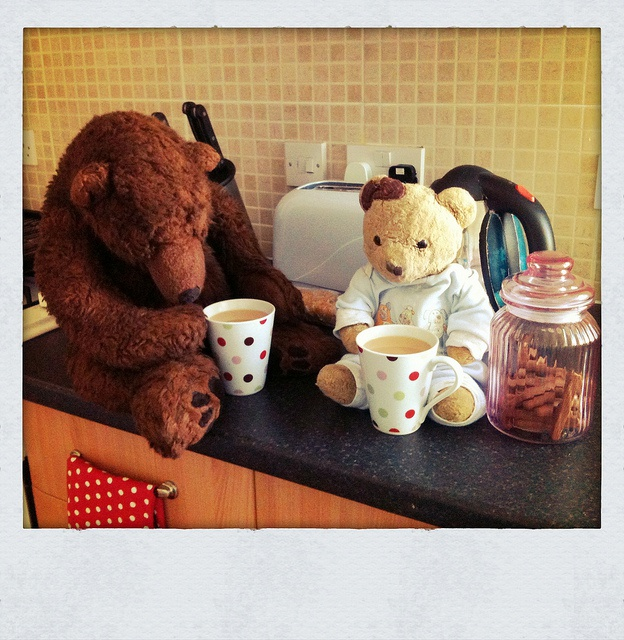Describe the objects in this image and their specific colors. I can see teddy bear in lightgray, black, maroon, and brown tones, teddy bear in lightgray, ivory, khaki, gray, and tan tones, bottle in lightgray, brown, maroon, and tan tones, toaster in lightgray, tan, and gray tones, and cup in lightgray, ivory, and tan tones in this image. 